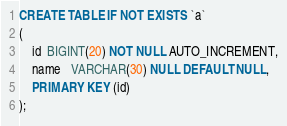<code> <loc_0><loc_0><loc_500><loc_500><_SQL_>CREATE TABLE IF NOT EXISTS `a`
(
    id  BIGINT(20) NOT NULL AUTO_INCREMENT,
    name   VARCHAR(30) NULL DEFAULT NULL,
    PRIMARY KEY (id)
);</code> 